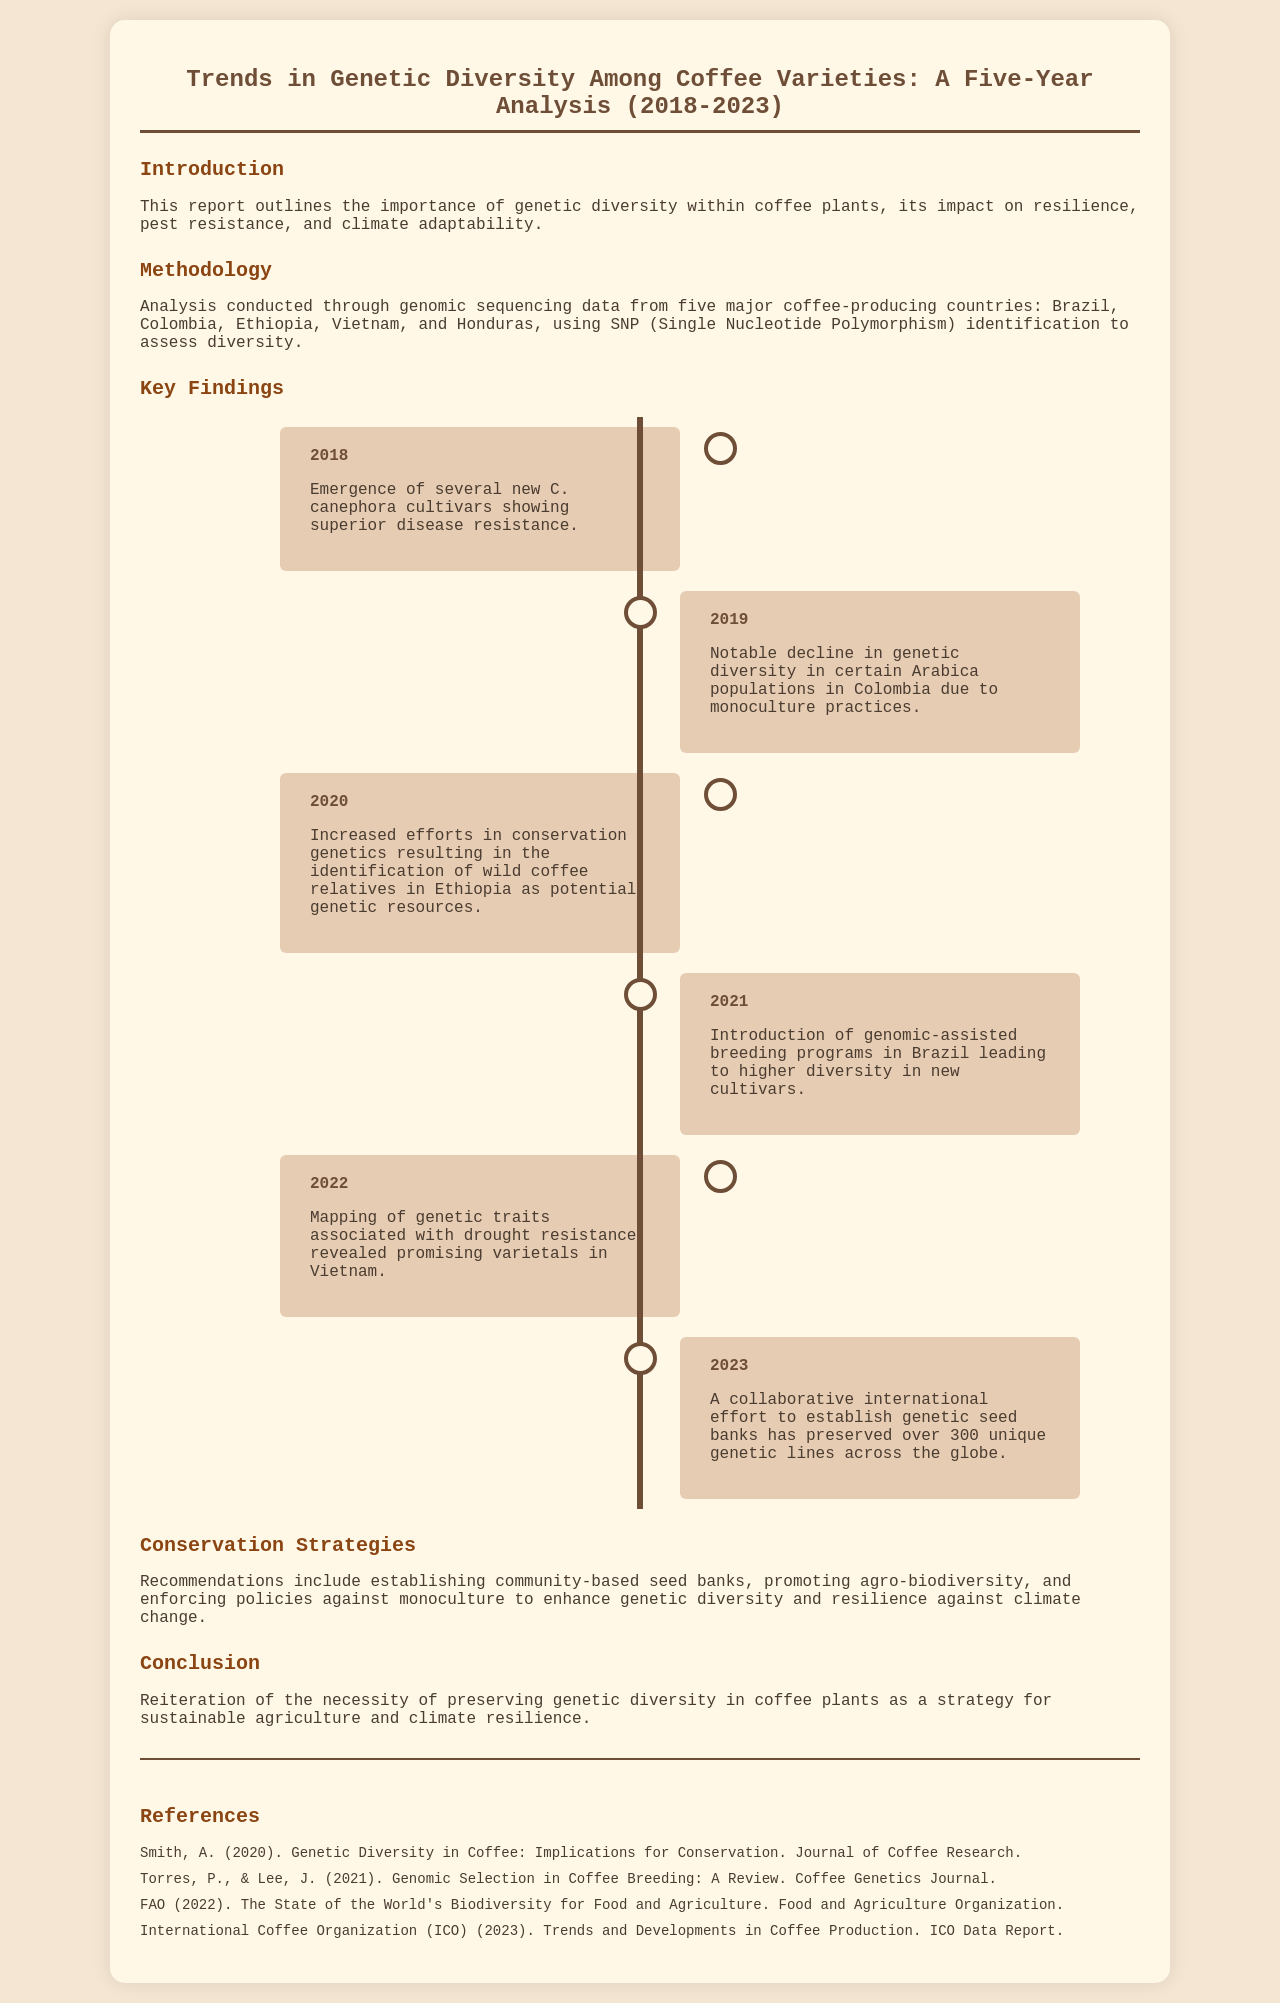What is the title of the report? The title of the report is found at the top of the document, focusing on trends in genetic diversity among coffee varieties over five years.
Answer: Trends in Genetic Diversity Among Coffee Varieties: A Five-Year Analysis (2018-2023) In which year did the introduction of genomic-assisted breeding programs occur? The document outlines specific years for significant findings, identifying 2021 as the year for genomic-assisted breeding programs in Brazil.
Answer: 2021 What was mapped in 2022? The document states that in 2022, genetic traits associated with drought resistance were mapped, providing insights into varietals.
Answer: Genetic traits associated with drought resistance How many unique genetic lines were preserved by 2023? The text mentions that by 2023, over 300 unique genetic lines were preserved as part of a collaborative effort.
Answer: Over 300 Which country is highlighted for identifying wild coffee relatives as genetic resources? The report discusses various coffee-producing countries, specifically emphasizing Ethiopia for the identification of wild coffee relatives.
Answer: Ethiopia What is one of the conservation strategies recommended? The document provides several conservation strategies, including establishing community-based seed banks as a significant recommendation.
Answer: Establishing community-based seed banks What decline was observed in Colombia in 2019? The report indicates a notable decline in genetic diversity in certain Arabica populations within Colombia in 2019 due to certain practices.
Answer: Genetic diversity in certain Arabica populations What was the significance of 2018 in the findings? The document highlights that in 2018, several new C. canephora cultivars were noted for showing superior disease resistance, marking an important development.
Answer: New C. canephora cultivars showing superior disease resistance 